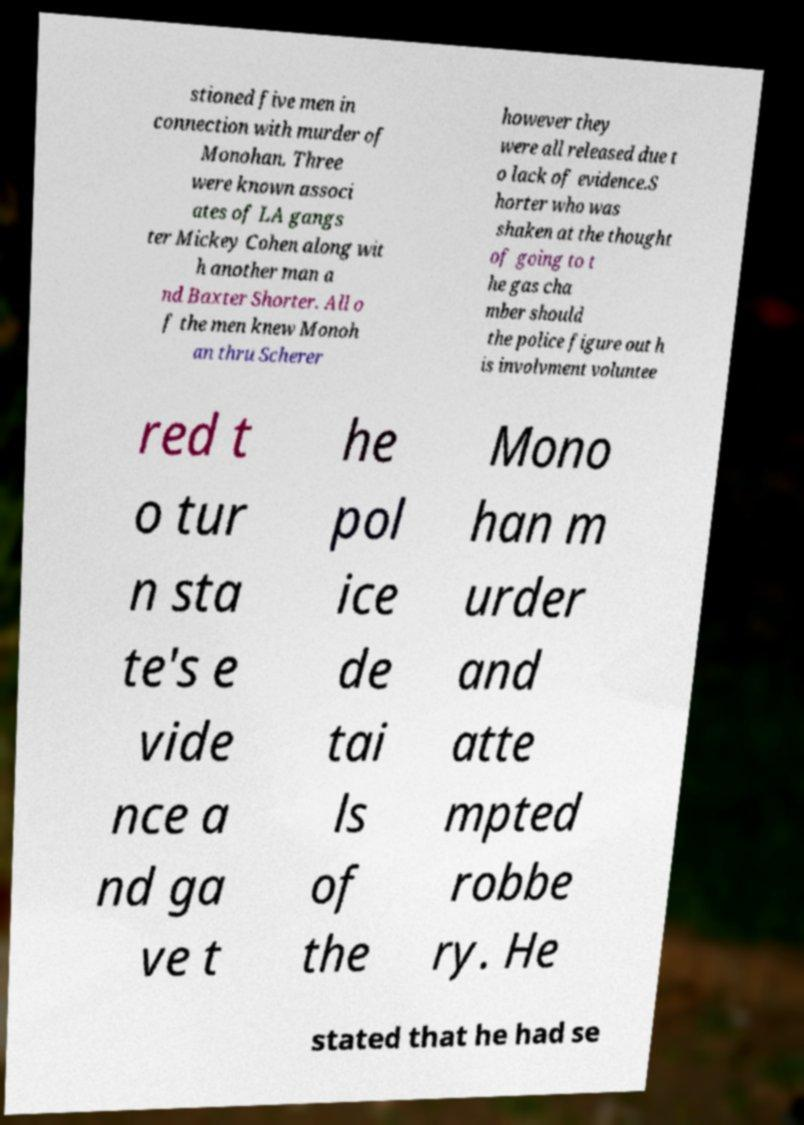Could you assist in decoding the text presented in this image and type it out clearly? stioned five men in connection with murder of Monohan. Three were known associ ates of LA gangs ter Mickey Cohen along wit h another man a nd Baxter Shorter. All o f the men knew Monoh an thru Scherer however they were all released due t o lack of evidence.S horter who was shaken at the thought of going to t he gas cha mber should the police figure out h is involvment voluntee red t o tur n sta te's e vide nce a nd ga ve t he pol ice de tai ls of the Mono han m urder and atte mpted robbe ry. He stated that he had se 